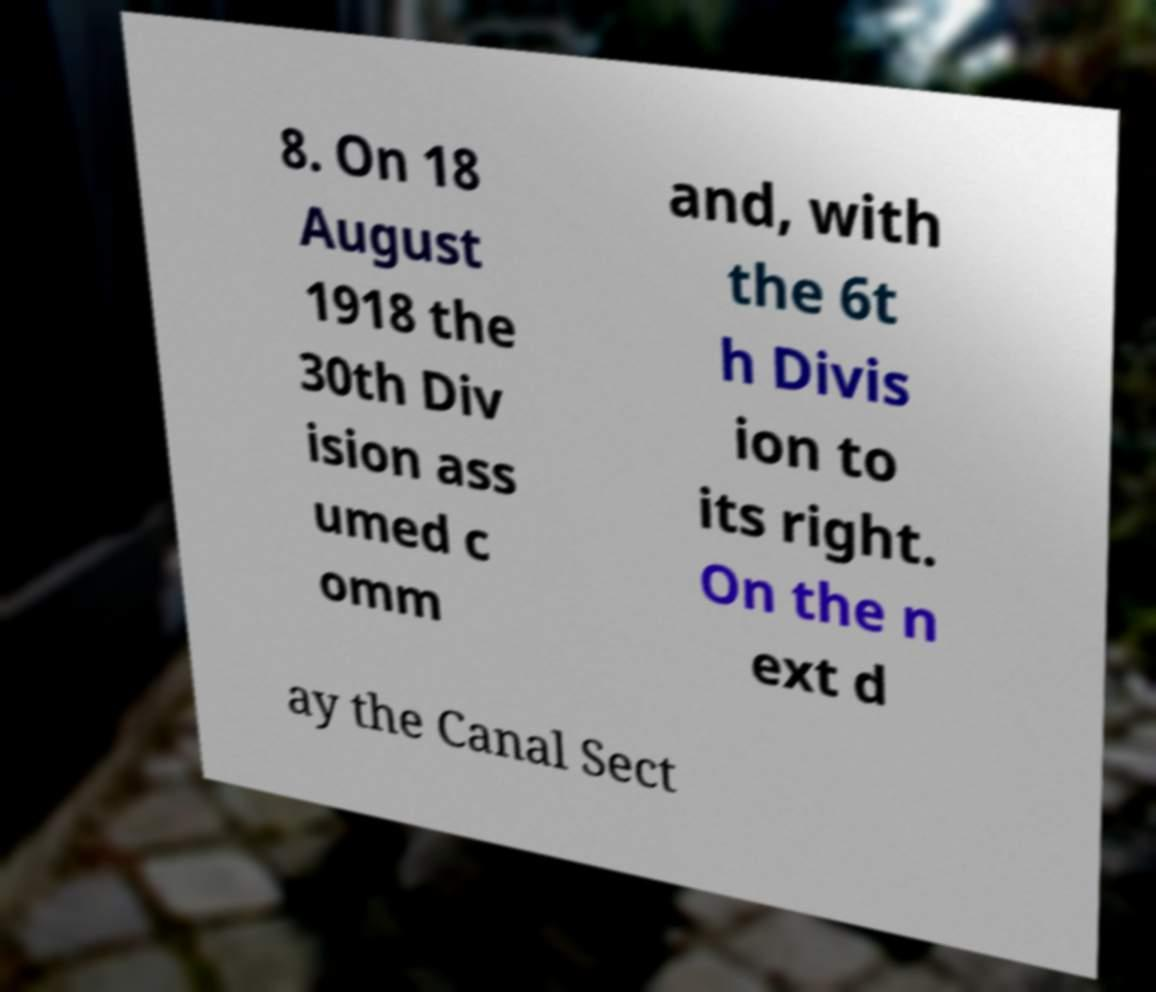Can you accurately transcribe the text from the provided image for me? 8. On 18 August 1918 the 30th Div ision ass umed c omm and, with the 6t h Divis ion to its right. On the n ext d ay the Canal Sect 